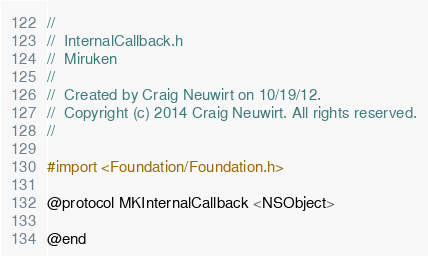Convert code to text. <code><loc_0><loc_0><loc_500><loc_500><_C_>//
//  InternalCallback.h
//  Miruken
//
//  Created by Craig Neuwirt on 10/19/12.
//  Copyright (c) 2014 Craig Neuwirt. All rights reserved.
//

#import <Foundation/Foundation.h>

@protocol MKInternalCallback <NSObject>

@end
</code> 